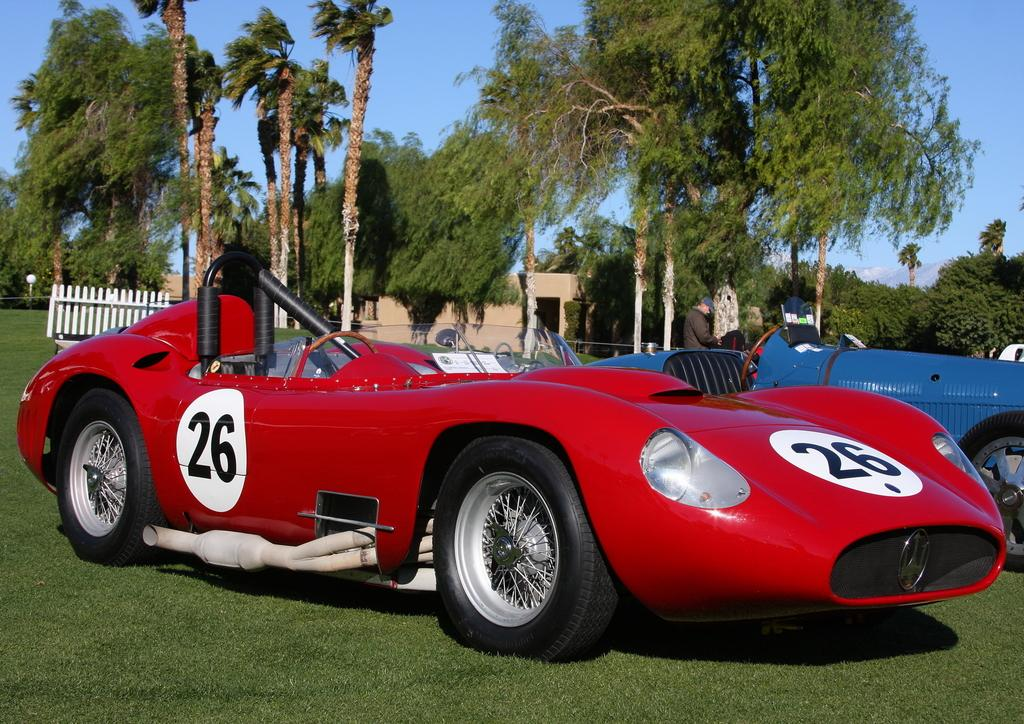What is located on the grass in the image? There are vehicles on the grass in the image. Can you describe the person in the image? There is a person standing in the image. What can be seen in the background of the image? There are trees, the sky, a house, a fence, and a light visible in the background. What type of attraction can be seen near the river in the image? There is no river or attraction present in the image. Can you describe the mother in the image? There is no mother present in the image. 